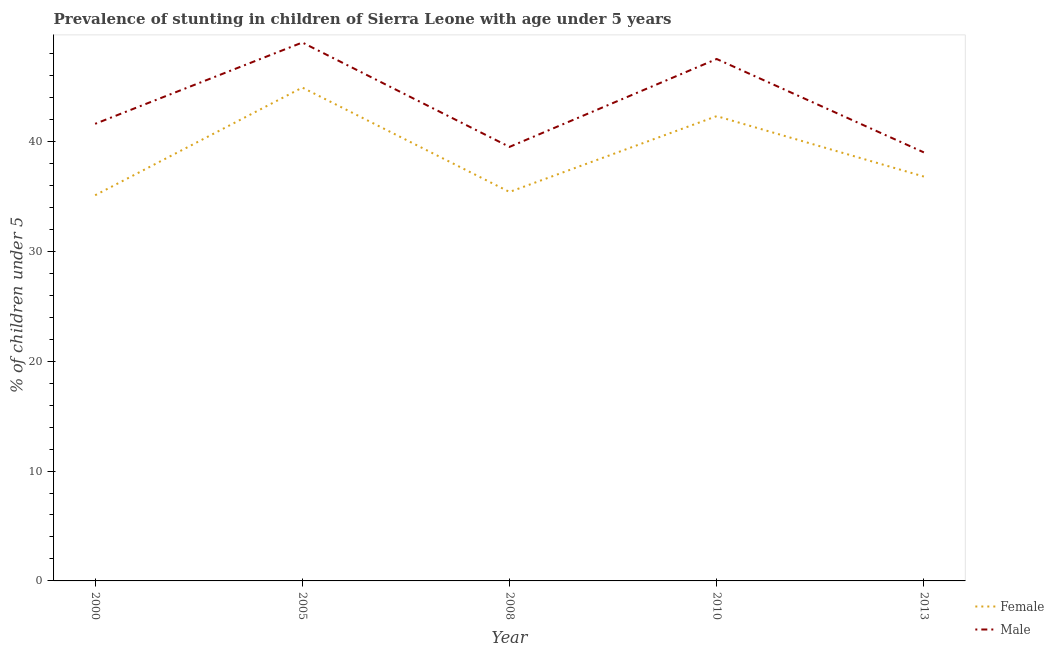Does the line corresponding to percentage of stunted male children intersect with the line corresponding to percentage of stunted female children?
Make the answer very short. No. What is the percentage of stunted female children in 2010?
Make the answer very short. 42.3. What is the total percentage of stunted male children in the graph?
Provide a succinct answer. 216.6. What is the difference between the percentage of stunted male children in 2000 and that in 2013?
Your response must be concise. 2.6. What is the difference between the percentage of stunted female children in 2013 and the percentage of stunted male children in 2010?
Keep it short and to the point. -10.7. What is the average percentage of stunted male children per year?
Your response must be concise. 43.32. In the year 2013, what is the difference between the percentage of stunted male children and percentage of stunted female children?
Give a very brief answer. 2.2. What is the ratio of the percentage of stunted female children in 2008 to that in 2013?
Your answer should be compact. 0.96. Is the difference between the percentage of stunted female children in 2005 and 2010 greater than the difference between the percentage of stunted male children in 2005 and 2010?
Make the answer very short. Yes. What is the difference between the highest and the second highest percentage of stunted male children?
Offer a terse response. 1.5. What is the difference between the highest and the lowest percentage of stunted female children?
Your response must be concise. 9.8. In how many years, is the percentage of stunted male children greater than the average percentage of stunted male children taken over all years?
Ensure brevity in your answer.  2. Is the sum of the percentage of stunted male children in 2000 and 2008 greater than the maximum percentage of stunted female children across all years?
Provide a succinct answer. Yes. How many lines are there?
Keep it short and to the point. 2. How many years are there in the graph?
Your answer should be very brief. 5. What is the difference between two consecutive major ticks on the Y-axis?
Make the answer very short. 10. Are the values on the major ticks of Y-axis written in scientific E-notation?
Keep it short and to the point. No. Does the graph contain any zero values?
Offer a very short reply. No. Where does the legend appear in the graph?
Keep it short and to the point. Bottom right. What is the title of the graph?
Your answer should be compact. Prevalence of stunting in children of Sierra Leone with age under 5 years. What is the label or title of the X-axis?
Your answer should be very brief. Year. What is the label or title of the Y-axis?
Your response must be concise.  % of children under 5. What is the  % of children under 5 of Female in 2000?
Provide a succinct answer. 35.1. What is the  % of children under 5 of Male in 2000?
Provide a succinct answer. 41.6. What is the  % of children under 5 of Female in 2005?
Your answer should be very brief. 44.9. What is the  % of children under 5 in Male in 2005?
Ensure brevity in your answer.  49. What is the  % of children under 5 of Female in 2008?
Your response must be concise. 35.4. What is the  % of children under 5 of Male in 2008?
Make the answer very short. 39.5. What is the  % of children under 5 in Female in 2010?
Keep it short and to the point. 42.3. What is the  % of children under 5 of Male in 2010?
Offer a very short reply. 47.5. What is the  % of children under 5 in Female in 2013?
Give a very brief answer. 36.8. What is the  % of children under 5 in Male in 2013?
Offer a very short reply. 39. Across all years, what is the maximum  % of children under 5 of Female?
Give a very brief answer. 44.9. Across all years, what is the minimum  % of children under 5 of Female?
Make the answer very short. 35.1. Across all years, what is the minimum  % of children under 5 in Male?
Your answer should be very brief. 39. What is the total  % of children under 5 in Female in the graph?
Your answer should be compact. 194.5. What is the total  % of children under 5 of Male in the graph?
Make the answer very short. 216.6. What is the difference between the  % of children under 5 in Female in 2000 and that in 2005?
Ensure brevity in your answer.  -9.8. What is the difference between the  % of children under 5 of Male in 2000 and that in 2005?
Provide a short and direct response. -7.4. What is the difference between the  % of children under 5 in Male in 2000 and that in 2008?
Offer a very short reply. 2.1. What is the difference between the  % of children under 5 of Female in 2000 and that in 2013?
Your response must be concise. -1.7. What is the difference between the  % of children under 5 of Female in 2005 and that in 2008?
Keep it short and to the point. 9.5. What is the difference between the  % of children under 5 of Female in 2005 and that in 2010?
Provide a succinct answer. 2.6. What is the difference between the  % of children under 5 in Male in 2005 and that in 2010?
Make the answer very short. 1.5. What is the difference between the  % of children under 5 of Female in 2005 and that in 2013?
Offer a terse response. 8.1. What is the difference between the  % of children under 5 in Female in 2008 and that in 2010?
Your response must be concise. -6.9. What is the difference between the  % of children under 5 in Male in 2008 and that in 2010?
Provide a short and direct response. -8. What is the difference between the  % of children under 5 of Female in 2010 and that in 2013?
Offer a terse response. 5.5. What is the difference between the  % of children under 5 of Female in 2000 and the  % of children under 5 of Male in 2008?
Offer a terse response. -4.4. What is the difference between the  % of children under 5 in Female in 2000 and the  % of children under 5 in Male in 2013?
Your response must be concise. -3.9. What is the difference between the  % of children under 5 in Female in 2005 and the  % of children under 5 in Male in 2010?
Provide a short and direct response. -2.6. What is the difference between the  % of children under 5 in Female in 2008 and the  % of children under 5 in Male in 2013?
Make the answer very short. -3.6. What is the average  % of children under 5 in Female per year?
Your answer should be very brief. 38.9. What is the average  % of children under 5 of Male per year?
Offer a very short reply. 43.32. In the year 2000, what is the difference between the  % of children under 5 of Female and  % of children under 5 of Male?
Provide a succinct answer. -6.5. In the year 2008, what is the difference between the  % of children under 5 of Female and  % of children under 5 of Male?
Your response must be concise. -4.1. What is the ratio of the  % of children under 5 of Female in 2000 to that in 2005?
Provide a succinct answer. 0.78. What is the ratio of the  % of children under 5 in Male in 2000 to that in 2005?
Your answer should be compact. 0.85. What is the ratio of the  % of children under 5 in Male in 2000 to that in 2008?
Your response must be concise. 1.05. What is the ratio of the  % of children under 5 of Female in 2000 to that in 2010?
Your answer should be very brief. 0.83. What is the ratio of the  % of children under 5 in Male in 2000 to that in 2010?
Provide a short and direct response. 0.88. What is the ratio of the  % of children under 5 in Female in 2000 to that in 2013?
Your response must be concise. 0.95. What is the ratio of the  % of children under 5 of Male in 2000 to that in 2013?
Your response must be concise. 1.07. What is the ratio of the  % of children under 5 of Female in 2005 to that in 2008?
Offer a very short reply. 1.27. What is the ratio of the  % of children under 5 of Male in 2005 to that in 2008?
Make the answer very short. 1.24. What is the ratio of the  % of children under 5 in Female in 2005 to that in 2010?
Give a very brief answer. 1.06. What is the ratio of the  % of children under 5 of Male in 2005 to that in 2010?
Offer a very short reply. 1.03. What is the ratio of the  % of children under 5 of Female in 2005 to that in 2013?
Keep it short and to the point. 1.22. What is the ratio of the  % of children under 5 in Male in 2005 to that in 2013?
Provide a succinct answer. 1.26. What is the ratio of the  % of children under 5 in Female in 2008 to that in 2010?
Your response must be concise. 0.84. What is the ratio of the  % of children under 5 in Male in 2008 to that in 2010?
Your answer should be compact. 0.83. What is the ratio of the  % of children under 5 of Male in 2008 to that in 2013?
Provide a short and direct response. 1.01. What is the ratio of the  % of children under 5 of Female in 2010 to that in 2013?
Provide a succinct answer. 1.15. What is the ratio of the  % of children under 5 of Male in 2010 to that in 2013?
Offer a very short reply. 1.22. 